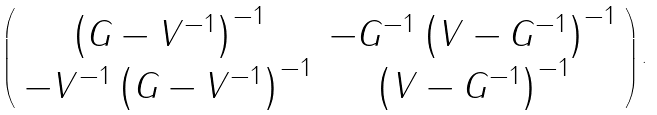Convert formula to latex. <formula><loc_0><loc_0><loc_500><loc_500>\left ( \begin{array} { c c } \left ( G - V ^ { - 1 } \right ) ^ { - 1 } & - G ^ { - 1 } \left ( V - G ^ { - 1 } \right ) ^ { - 1 } \\ - V ^ { - 1 } \left ( G - V ^ { - 1 } \right ) ^ { - 1 } & \left ( V - G ^ { - 1 } \right ) ^ { - 1 } \end{array} \right ) .</formula> 